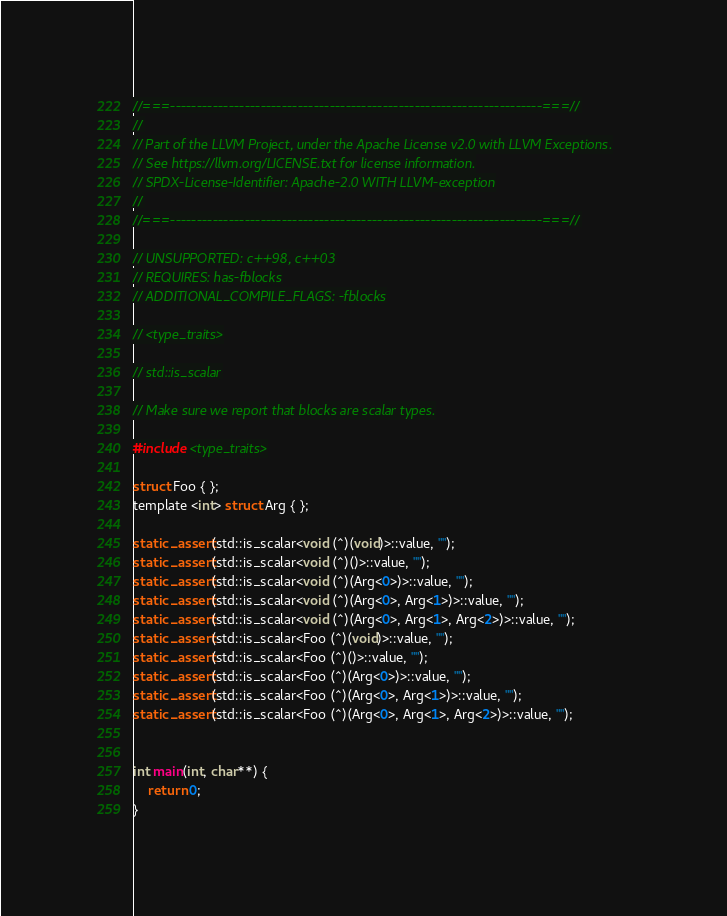Convert code to text. <code><loc_0><loc_0><loc_500><loc_500><_ObjectiveC_>//===----------------------------------------------------------------------===//
//
// Part of the LLVM Project, under the Apache License v2.0 with LLVM Exceptions.
// See https://llvm.org/LICENSE.txt for license information.
// SPDX-License-Identifier: Apache-2.0 WITH LLVM-exception
//
//===----------------------------------------------------------------------===//

// UNSUPPORTED: c++98, c++03
// REQUIRES: has-fblocks
// ADDITIONAL_COMPILE_FLAGS: -fblocks

// <type_traits>

// std::is_scalar

// Make sure we report that blocks are scalar types.

#include <type_traits>

struct Foo { };
template <int> struct Arg { };

static_assert(std::is_scalar<void (^)(void)>::value, "");
static_assert(std::is_scalar<void (^)()>::value, "");
static_assert(std::is_scalar<void (^)(Arg<0>)>::value, "");
static_assert(std::is_scalar<void (^)(Arg<0>, Arg<1>)>::value, "");
static_assert(std::is_scalar<void (^)(Arg<0>, Arg<1>, Arg<2>)>::value, "");
static_assert(std::is_scalar<Foo (^)(void)>::value, "");
static_assert(std::is_scalar<Foo (^)()>::value, "");
static_assert(std::is_scalar<Foo (^)(Arg<0>)>::value, "");
static_assert(std::is_scalar<Foo (^)(Arg<0>, Arg<1>)>::value, "");
static_assert(std::is_scalar<Foo (^)(Arg<0>, Arg<1>, Arg<2>)>::value, "");


int main(int, char**) {
    return 0;
}
</code> 